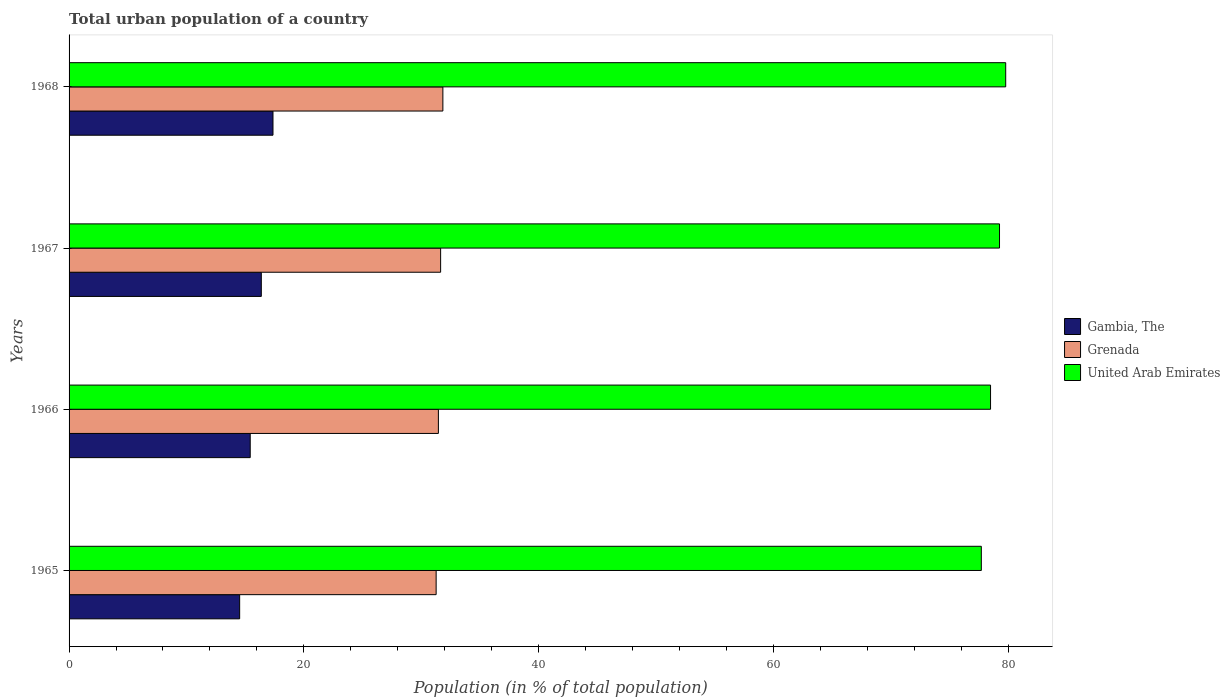How many groups of bars are there?
Make the answer very short. 4. Are the number of bars per tick equal to the number of legend labels?
Provide a succinct answer. Yes. How many bars are there on the 3rd tick from the bottom?
Your response must be concise. 3. What is the label of the 2nd group of bars from the top?
Give a very brief answer. 1967. In how many cases, is the number of bars for a given year not equal to the number of legend labels?
Make the answer very short. 0. What is the urban population in United Arab Emirates in 1968?
Your answer should be compact. 79.8. Across all years, what is the maximum urban population in Gambia, The?
Make the answer very short. 17.37. Across all years, what is the minimum urban population in Grenada?
Provide a succinct answer. 31.27. In which year was the urban population in United Arab Emirates maximum?
Your response must be concise. 1968. In which year was the urban population in Gambia, The minimum?
Your answer should be very brief. 1965. What is the total urban population in Grenada in the graph?
Your answer should be compact. 126.24. What is the difference between the urban population in Grenada in 1966 and that in 1968?
Provide a short and direct response. -0.38. What is the difference between the urban population in Grenada in 1965 and the urban population in United Arab Emirates in 1968?
Your answer should be compact. -48.53. What is the average urban population in United Arab Emirates per year?
Give a very brief answer. 78.83. In the year 1968, what is the difference between the urban population in Grenada and urban population in United Arab Emirates?
Make the answer very short. -47.95. What is the ratio of the urban population in Gambia, The in 1965 to that in 1968?
Your answer should be compact. 0.84. Is the urban population in Gambia, The in 1965 less than that in 1968?
Your answer should be very brief. Yes. What is the difference between the highest and the second highest urban population in Gambia, The?
Your response must be concise. 0.99. What is the difference between the highest and the lowest urban population in Grenada?
Offer a terse response. 0.57. In how many years, is the urban population in United Arab Emirates greater than the average urban population in United Arab Emirates taken over all years?
Your response must be concise. 2. What does the 3rd bar from the top in 1966 represents?
Provide a succinct answer. Gambia, The. What does the 3rd bar from the bottom in 1966 represents?
Provide a short and direct response. United Arab Emirates. Is it the case that in every year, the sum of the urban population in Gambia, The and urban population in United Arab Emirates is greater than the urban population in Grenada?
Offer a very short reply. Yes. What is the difference between two consecutive major ticks on the X-axis?
Your answer should be compact. 20. Are the values on the major ticks of X-axis written in scientific E-notation?
Make the answer very short. No. Where does the legend appear in the graph?
Your answer should be compact. Center right. What is the title of the graph?
Give a very brief answer. Total urban population of a country. Does "Rwanda" appear as one of the legend labels in the graph?
Your answer should be compact. No. What is the label or title of the X-axis?
Provide a short and direct response. Population (in % of total population). What is the label or title of the Y-axis?
Your answer should be compact. Years. What is the Population (in % of total population) of Gambia, The in 1965?
Keep it short and to the point. 14.53. What is the Population (in % of total population) in Grenada in 1965?
Ensure brevity in your answer.  31.27. What is the Population (in % of total population) of United Arab Emirates in 1965?
Offer a terse response. 77.72. What is the Population (in % of total population) of Gambia, The in 1966?
Your response must be concise. 15.43. What is the Population (in % of total population) in Grenada in 1966?
Your answer should be very brief. 31.46. What is the Population (in % of total population) of United Arab Emirates in 1966?
Offer a very short reply. 78.51. What is the Population (in % of total population) of Gambia, The in 1967?
Offer a terse response. 16.38. What is the Population (in % of total population) in Grenada in 1967?
Your answer should be compact. 31.66. What is the Population (in % of total population) of United Arab Emirates in 1967?
Provide a succinct answer. 79.27. What is the Population (in % of total population) in Gambia, The in 1968?
Ensure brevity in your answer.  17.37. What is the Population (in % of total population) in Grenada in 1968?
Provide a succinct answer. 31.85. What is the Population (in % of total population) of United Arab Emirates in 1968?
Ensure brevity in your answer.  79.8. Across all years, what is the maximum Population (in % of total population) in Gambia, The?
Provide a short and direct response. 17.37. Across all years, what is the maximum Population (in % of total population) of Grenada?
Your answer should be compact. 31.85. Across all years, what is the maximum Population (in % of total population) of United Arab Emirates?
Provide a short and direct response. 79.8. Across all years, what is the minimum Population (in % of total population) in Gambia, The?
Your answer should be very brief. 14.53. Across all years, what is the minimum Population (in % of total population) in Grenada?
Your answer should be compact. 31.27. Across all years, what is the minimum Population (in % of total population) of United Arab Emirates?
Your answer should be compact. 77.72. What is the total Population (in % of total population) of Gambia, The in the graph?
Provide a succinct answer. 63.72. What is the total Population (in % of total population) of Grenada in the graph?
Offer a terse response. 126.24. What is the total Population (in % of total population) in United Arab Emirates in the graph?
Give a very brief answer. 315.3. What is the difference between the Population (in % of total population) of Gambia, The in 1965 and that in 1966?
Provide a succinct answer. -0.9. What is the difference between the Population (in % of total population) of Grenada in 1965 and that in 1966?
Provide a succinct answer. -0.19. What is the difference between the Population (in % of total population) of United Arab Emirates in 1965 and that in 1966?
Provide a short and direct response. -0.79. What is the difference between the Population (in % of total population) in Gambia, The in 1965 and that in 1967?
Provide a short and direct response. -1.85. What is the difference between the Population (in % of total population) of Grenada in 1965 and that in 1967?
Provide a short and direct response. -0.38. What is the difference between the Population (in % of total population) of United Arab Emirates in 1965 and that in 1967?
Give a very brief answer. -1.55. What is the difference between the Population (in % of total population) of Gambia, The in 1965 and that in 1968?
Your response must be concise. -2.84. What is the difference between the Population (in % of total population) in Grenada in 1965 and that in 1968?
Give a very brief answer. -0.57. What is the difference between the Population (in % of total population) of United Arab Emirates in 1965 and that in 1968?
Provide a succinct answer. -2.08. What is the difference between the Population (in % of total population) of Gambia, The in 1966 and that in 1967?
Ensure brevity in your answer.  -0.95. What is the difference between the Population (in % of total population) in Grenada in 1966 and that in 1967?
Keep it short and to the point. -0.19. What is the difference between the Population (in % of total population) of United Arab Emirates in 1966 and that in 1967?
Ensure brevity in your answer.  -0.76. What is the difference between the Population (in % of total population) of Gambia, The in 1966 and that in 1968?
Provide a short and direct response. -1.94. What is the difference between the Population (in % of total population) of Grenada in 1966 and that in 1968?
Your answer should be very brief. -0.38. What is the difference between the Population (in % of total population) in United Arab Emirates in 1966 and that in 1968?
Offer a very short reply. -1.29. What is the difference between the Population (in % of total population) in Gambia, The in 1967 and that in 1968?
Your answer should be compact. -0.99. What is the difference between the Population (in % of total population) of Grenada in 1967 and that in 1968?
Your answer should be very brief. -0.19. What is the difference between the Population (in % of total population) in United Arab Emirates in 1967 and that in 1968?
Give a very brief answer. -0.53. What is the difference between the Population (in % of total population) of Gambia, The in 1965 and the Population (in % of total population) of Grenada in 1966?
Provide a short and direct response. -16.93. What is the difference between the Population (in % of total population) of Gambia, The in 1965 and the Population (in % of total population) of United Arab Emirates in 1966?
Your response must be concise. -63.98. What is the difference between the Population (in % of total population) in Grenada in 1965 and the Population (in % of total population) in United Arab Emirates in 1966?
Give a very brief answer. -47.23. What is the difference between the Population (in % of total population) in Gambia, The in 1965 and the Population (in % of total population) in Grenada in 1967?
Give a very brief answer. -17.12. What is the difference between the Population (in % of total population) in Gambia, The in 1965 and the Population (in % of total population) in United Arab Emirates in 1967?
Your answer should be compact. -64.74. What is the difference between the Population (in % of total population) in Grenada in 1965 and the Population (in % of total population) in United Arab Emirates in 1967?
Offer a very short reply. -48. What is the difference between the Population (in % of total population) in Gambia, The in 1965 and the Population (in % of total population) in Grenada in 1968?
Offer a terse response. -17.32. What is the difference between the Population (in % of total population) in Gambia, The in 1965 and the Population (in % of total population) in United Arab Emirates in 1968?
Your response must be concise. -65.27. What is the difference between the Population (in % of total population) in Grenada in 1965 and the Population (in % of total population) in United Arab Emirates in 1968?
Provide a short and direct response. -48.53. What is the difference between the Population (in % of total population) of Gambia, The in 1966 and the Population (in % of total population) of Grenada in 1967?
Make the answer very short. -16.22. What is the difference between the Population (in % of total population) in Gambia, The in 1966 and the Population (in % of total population) in United Arab Emirates in 1967?
Your response must be concise. -63.84. What is the difference between the Population (in % of total population) of Grenada in 1966 and the Population (in % of total population) of United Arab Emirates in 1967?
Make the answer very short. -47.81. What is the difference between the Population (in % of total population) in Gambia, The in 1966 and the Population (in % of total population) in Grenada in 1968?
Make the answer very short. -16.41. What is the difference between the Population (in % of total population) of Gambia, The in 1966 and the Population (in % of total population) of United Arab Emirates in 1968?
Offer a terse response. -64.37. What is the difference between the Population (in % of total population) in Grenada in 1966 and the Population (in % of total population) in United Arab Emirates in 1968?
Keep it short and to the point. -48.34. What is the difference between the Population (in % of total population) in Gambia, The in 1967 and the Population (in % of total population) in Grenada in 1968?
Offer a very short reply. -15.47. What is the difference between the Population (in % of total population) in Gambia, The in 1967 and the Population (in % of total population) in United Arab Emirates in 1968?
Provide a succinct answer. -63.42. What is the difference between the Population (in % of total population) of Grenada in 1967 and the Population (in % of total population) of United Arab Emirates in 1968?
Your answer should be very brief. -48.14. What is the average Population (in % of total population) of Gambia, The per year?
Your answer should be compact. 15.93. What is the average Population (in % of total population) in Grenada per year?
Offer a very short reply. 31.56. What is the average Population (in % of total population) of United Arab Emirates per year?
Keep it short and to the point. 78.83. In the year 1965, what is the difference between the Population (in % of total population) of Gambia, The and Population (in % of total population) of Grenada?
Provide a succinct answer. -16.74. In the year 1965, what is the difference between the Population (in % of total population) of Gambia, The and Population (in % of total population) of United Arab Emirates?
Offer a very short reply. -63.19. In the year 1965, what is the difference between the Population (in % of total population) of Grenada and Population (in % of total population) of United Arab Emirates?
Make the answer very short. -46.45. In the year 1966, what is the difference between the Population (in % of total population) of Gambia, The and Population (in % of total population) of Grenada?
Provide a short and direct response. -16.03. In the year 1966, what is the difference between the Population (in % of total population) of Gambia, The and Population (in % of total population) of United Arab Emirates?
Offer a very short reply. -63.08. In the year 1966, what is the difference between the Population (in % of total population) of Grenada and Population (in % of total population) of United Arab Emirates?
Make the answer very short. -47.04. In the year 1967, what is the difference between the Population (in % of total population) in Gambia, The and Population (in % of total population) in Grenada?
Offer a terse response. -15.28. In the year 1967, what is the difference between the Population (in % of total population) in Gambia, The and Population (in % of total population) in United Arab Emirates?
Give a very brief answer. -62.89. In the year 1967, what is the difference between the Population (in % of total population) in Grenada and Population (in % of total population) in United Arab Emirates?
Offer a very short reply. -47.62. In the year 1968, what is the difference between the Population (in % of total population) in Gambia, The and Population (in % of total population) in Grenada?
Provide a succinct answer. -14.47. In the year 1968, what is the difference between the Population (in % of total population) in Gambia, The and Population (in % of total population) in United Arab Emirates?
Offer a terse response. -62.43. In the year 1968, what is the difference between the Population (in % of total population) of Grenada and Population (in % of total population) of United Arab Emirates?
Provide a succinct answer. -47.95. What is the ratio of the Population (in % of total population) of Gambia, The in 1965 to that in 1966?
Your response must be concise. 0.94. What is the ratio of the Population (in % of total population) in Grenada in 1965 to that in 1966?
Offer a terse response. 0.99. What is the ratio of the Population (in % of total population) of United Arab Emirates in 1965 to that in 1966?
Provide a short and direct response. 0.99. What is the ratio of the Population (in % of total population) in Gambia, The in 1965 to that in 1967?
Offer a very short reply. 0.89. What is the ratio of the Population (in % of total population) in Grenada in 1965 to that in 1967?
Offer a terse response. 0.99. What is the ratio of the Population (in % of total population) in United Arab Emirates in 1965 to that in 1967?
Provide a short and direct response. 0.98. What is the ratio of the Population (in % of total population) of Gambia, The in 1965 to that in 1968?
Your answer should be very brief. 0.84. What is the ratio of the Population (in % of total population) in Gambia, The in 1966 to that in 1967?
Ensure brevity in your answer.  0.94. What is the ratio of the Population (in % of total population) of Gambia, The in 1966 to that in 1968?
Give a very brief answer. 0.89. What is the ratio of the Population (in % of total population) in Grenada in 1966 to that in 1968?
Offer a terse response. 0.99. What is the ratio of the Population (in % of total population) in United Arab Emirates in 1966 to that in 1968?
Your answer should be very brief. 0.98. What is the ratio of the Population (in % of total population) in Gambia, The in 1967 to that in 1968?
Keep it short and to the point. 0.94. What is the ratio of the Population (in % of total population) of Grenada in 1967 to that in 1968?
Offer a very short reply. 0.99. What is the ratio of the Population (in % of total population) of United Arab Emirates in 1967 to that in 1968?
Ensure brevity in your answer.  0.99. What is the difference between the highest and the second highest Population (in % of total population) in Gambia, The?
Make the answer very short. 0.99. What is the difference between the highest and the second highest Population (in % of total population) of Grenada?
Your answer should be compact. 0.19. What is the difference between the highest and the second highest Population (in % of total population) in United Arab Emirates?
Your answer should be compact. 0.53. What is the difference between the highest and the lowest Population (in % of total population) of Gambia, The?
Keep it short and to the point. 2.84. What is the difference between the highest and the lowest Population (in % of total population) of Grenada?
Offer a terse response. 0.57. What is the difference between the highest and the lowest Population (in % of total population) in United Arab Emirates?
Provide a succinct answer. 2.08. 